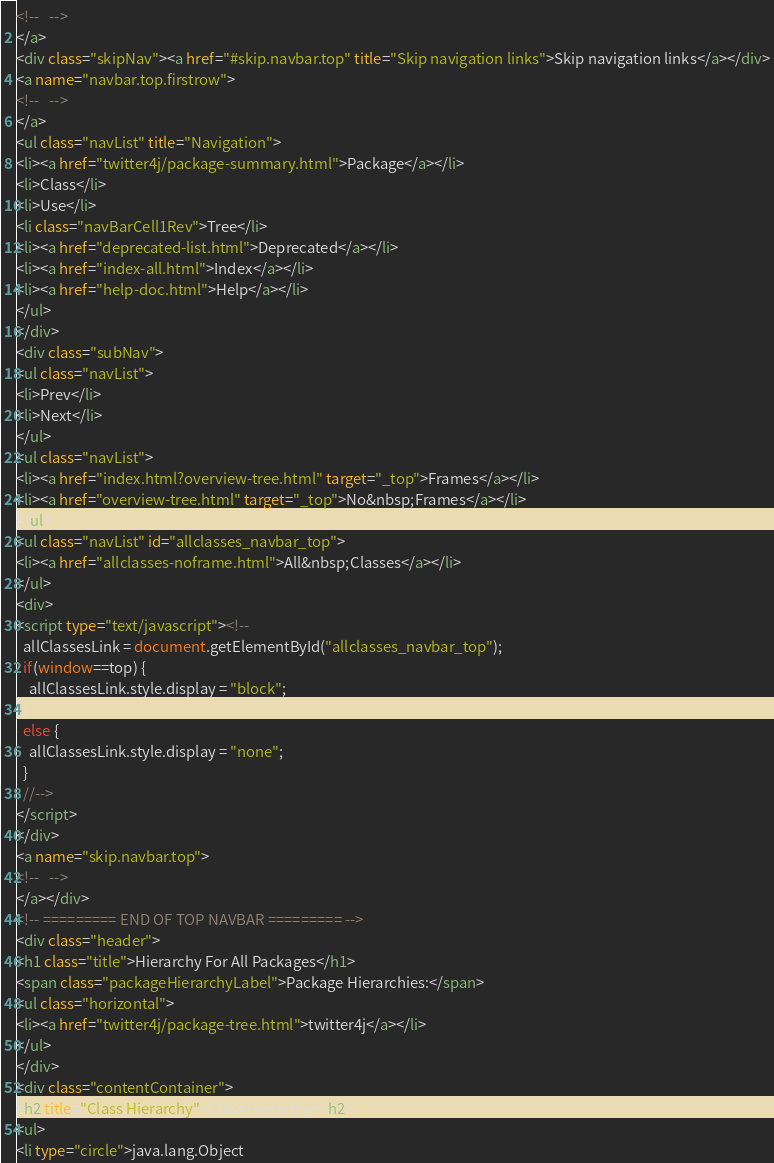<code> <loc_0><loc_0><loc_500><loc_500><_HTML_><!--   -->
</a>
<div class="skipNav"><a href="#skip.navbar.top" title="Skip navigation links">Skip navigation links</a></div>
<a name="navbar.top.firstrow">
<!--   -->
</a>
<ul class="navList" title="Navigation">
<li><a href="twitter4j/package-summary.html">Package</a></li>
<li>Class</li>
<li>Use</li>
<li class="navBarCell1Rev">Tree</li>
<li><a href="deprecated-list.html">Deprecated</a></li>
<li><a href="index-all.html">Index</a></li>
<li><a href="help-doc.html">Help</a></li>
</ul>
</div>
<div class="subNav">
<ul class="navList">
<li>Prev</li>
<li>Next</li>
</ul>
<ul class="navList">
<li><a href="index.html?overview-tree.html" target="_top">Frames</a></li>
<li><a href="overview-tree.html" target="_top">No&nbsp;Frames</a></li>
</ul>
<ul class="navList" id="allclasses_navbar_top">
<li><a href="allclasses-noframe.html">All&nbsp;Classes</a></li>
</ul>
<div>
<script type="text/javascript"><!--
  allClassesLink = document.getElementById("allclasses_navbar_top");
  if(window==top) {
    allClassesLink.style.display = "block";
  }
  else {
    allClassesLink.style.display = "none";
  }
  //-->
</script>
</div>
<a name="skip.navbar.top">
<!--   -->
</a></div>
<!-- ========= END OF TOP NAVBAR ========= -->
<div class="header">
<h1 class="title">Hierarchy For All Packages</h1>
<span class="packageHierarchyLabel">Package Hierarchies:</span>
<ul class="horizontal">
<li><a href="twitter4j/package-tree.html">twitter4j</a></li>
</ul>
</div>
<div class="contentContainer">
<h2 title="Class Hierarchy">Class Hierarchy</h2>
<ul>
<li type="circle">java.lang.Object</code> 